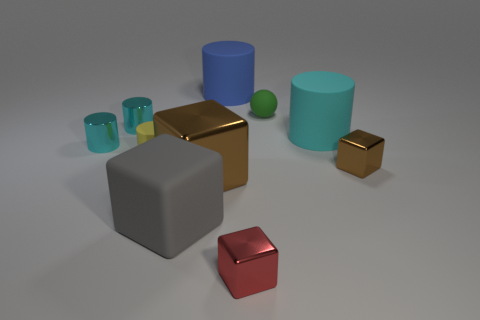Subtract all red blocks. How many cyan cylinders are left? 3 Subtract 1 cubes. How many cubes are left? 3 Subtract all large blue cylinders. How many cylinders are left? 4 Subtract all yellow cylinders. How many cylinders are left? 4 Subtract all green cylinders. Subtract all purple spheres. How many cylinders are left? 5 Subtract all blocks. How many objects are left? 6 Add 1 big brown metallic blocks. How many big brown metallic blocks are left? 2 Add 5 large brown metal objects. How many large brown metal objects exist? 6 Subtract 0 brown balls. How many objects are left? 10 Subtract all tiny red metallic cubes. Subtract all metal cylinders. How many objects are left? 7 